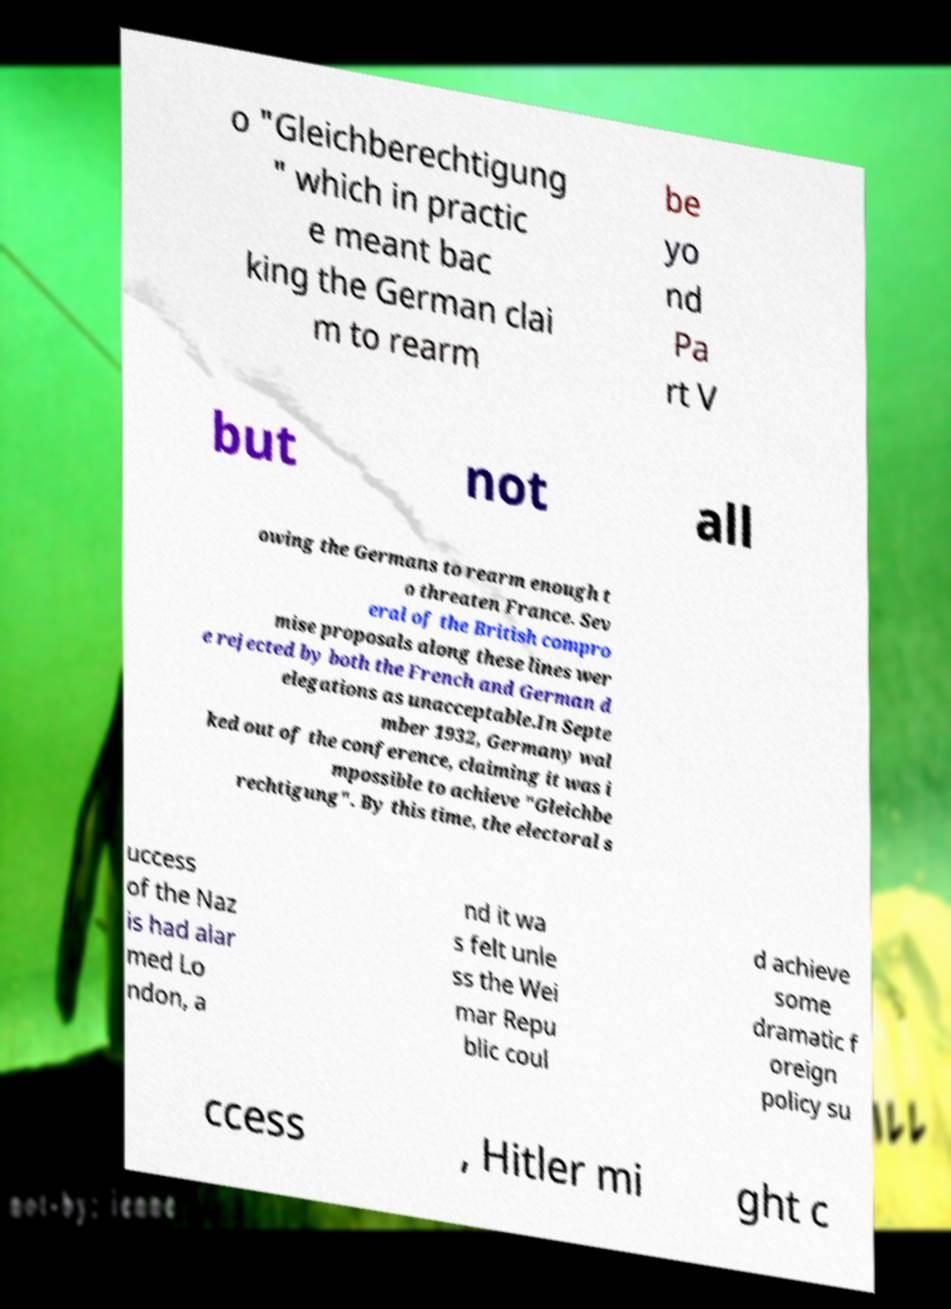Please read and relay the text visible in this image. What does it say? o "Gleichberechtigung " which in practic e meant bac king the German clai m to rearm be yo nd Pa rt V but not all owing the Germans to rearm enough t o threaten France. Sev eral of the British compro mise proposals along these lines wer e rejected by both the French and German d elegations as unacceptable.In Septe mber 1932, Germany wal ked out of the conference, claiming it was i mpossible to achieve "Gleichbe rechtigung". By this time, the electoral s uccess of the Naz is had alar med Lo ndon, a nd it wa s felt unle ss the Wei mar Repu blic coul d achieve some dramatic f oreign policy su ccess , Hitler mi ght c 